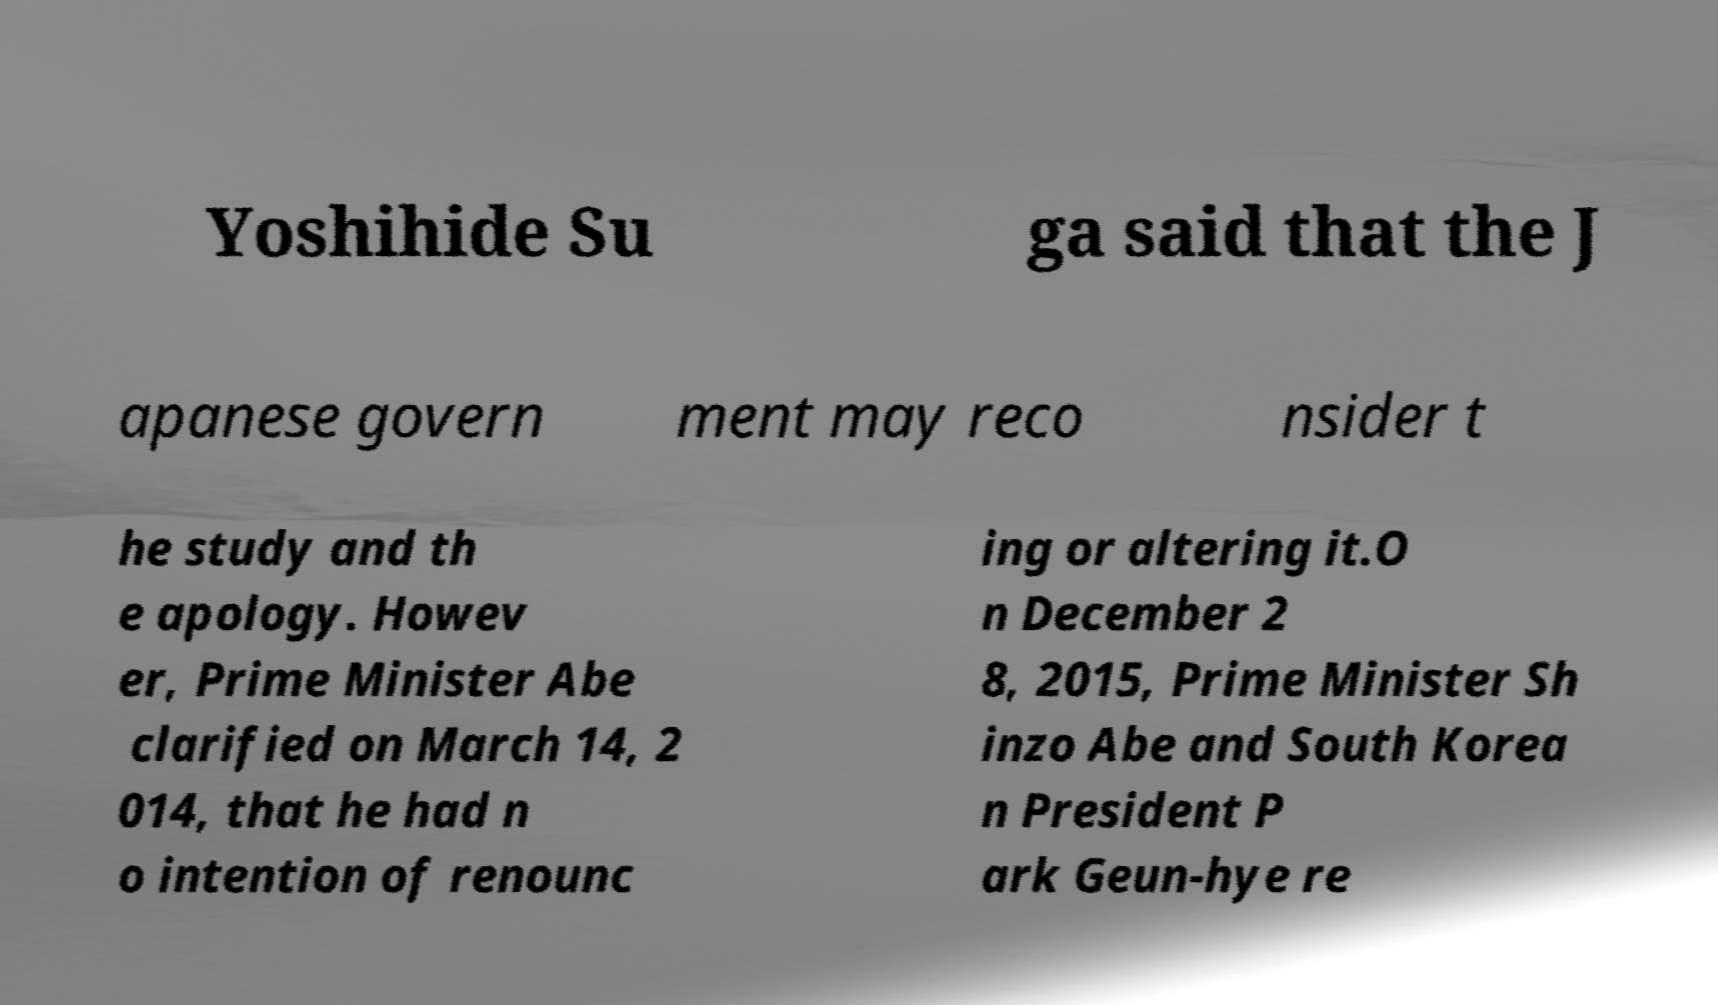Could you extract and type out the text from this image? Yoshihide Su ga said that the J apanese govern ment may reco nsider t he study and th e apology. Howev er, Prime Minister Abe clarified on March 14, 2 014, that he had n o intention of renounc ing or altering it.O n December 2 8, 2015, Prime Minister Sh inzo Abe and South Korea n President P ark Geun-hye re 